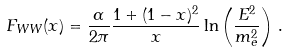Convert formula to latex. <formula><loc_0><loc_0><loc_500><loc_500>F _ { W W } ( x ) = \frac { \alpha } { 2 \pi } \frac { 1 + ( 1 - x ) ^ { 2 } } { x } \ln \left ( \frac { E ^ { 2 } } { m _ { e } ^ { 2 } } \right ) \, .</formula> 